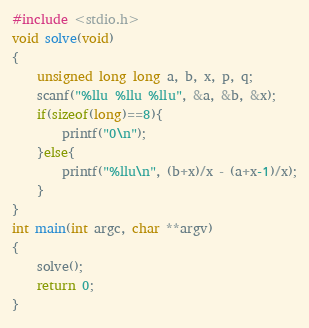<code> <loc_0><loc_0><loc_500><loc_500><_C_>#include <stdio.h>
void solve(void)
{
	unsigned long long a, b, x, p, q;
	scanf("%llu %llu %llu", &a, &b, &x);
	if(sizeof(long)==8){
		printf("0\n");
	}else{
		printf("%llu\n", (b+x)/x - (a+x-1)/x);
	}
}
int main(int argc, char **argv)
{
	solve();
	return 0;
}
</code> 